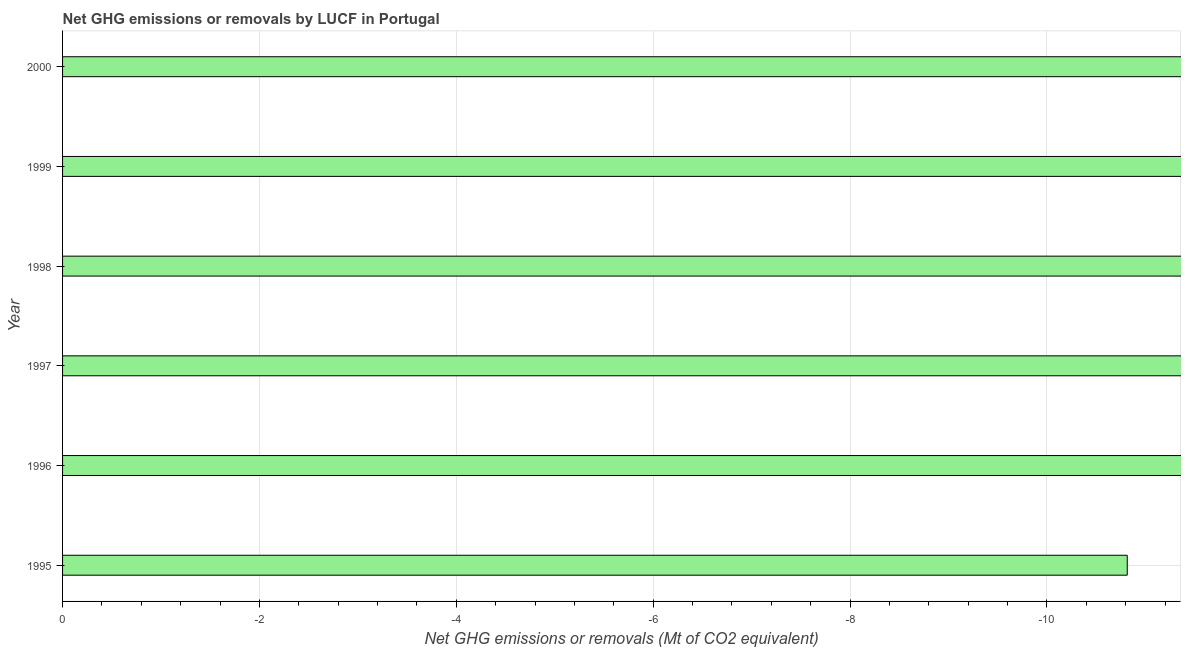What is the title of the graph?
Provide a short and direct response. Net GHG emissions or removals by LUCF in Portugal. What is the label or title of the X-axis?
Give a very brief answer. Net GHG emissions or removals (Mt of CO2 equivalent). What is the median ghg net emissions or removals?
Keep it short and to the point. 0. In how many years, is the ghg net emissions or removals greater than the average ghg net emissions or removals taken over all years?
Your answer should be very brief. 0. How many bars are there?
Your response must be concise. 0. What is the difference between two consecutive major ticks on the X-axis?
Provide a succinct answer. 2. Are the values on the major ticks of X-axis written in scientific E-notation?
Your answer should be very brief. No. What is the Net GHG emissions or removals (Mt of CO2 equivalent) in 1995?
Make the answer very short. 0. What is the Net GHG emissions or removals (Mt of CO2 equivalent) in 1996?
Your answer should be compact. 0. What is the Net GHG emissions or removals (Mt of CO2 equivalent) of 1997?
Provide a succinct answer. 0. What is the Net GHG emissions or removals (Mt of CO2 equivalent) of 1999?
Your response must be concise. 0. 